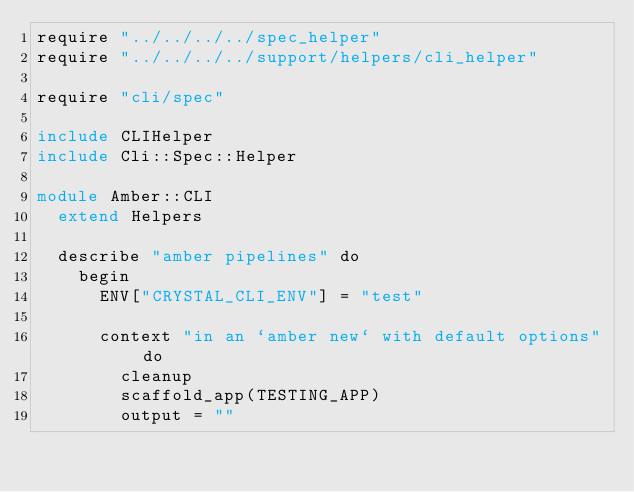<code> <loc_0><loc_0><loc_500><loc_500><_Crystal_>require "../../../../spec_helper"
require "../../../../support/helpers/cli_helper"

require "cli/spec"

include CLIHelper
include Cli::Spec::Helper

module Amber::CLI
  extend Helpers

  describe "amber pipelines" do
    begin
      ENV["CRYSTAL_CLI_ENV"] = "test"

      context "in an `amber new` with default options" do
        cleanup
        scaffold_app(TESTING_APP)
        output = ""
</code> 